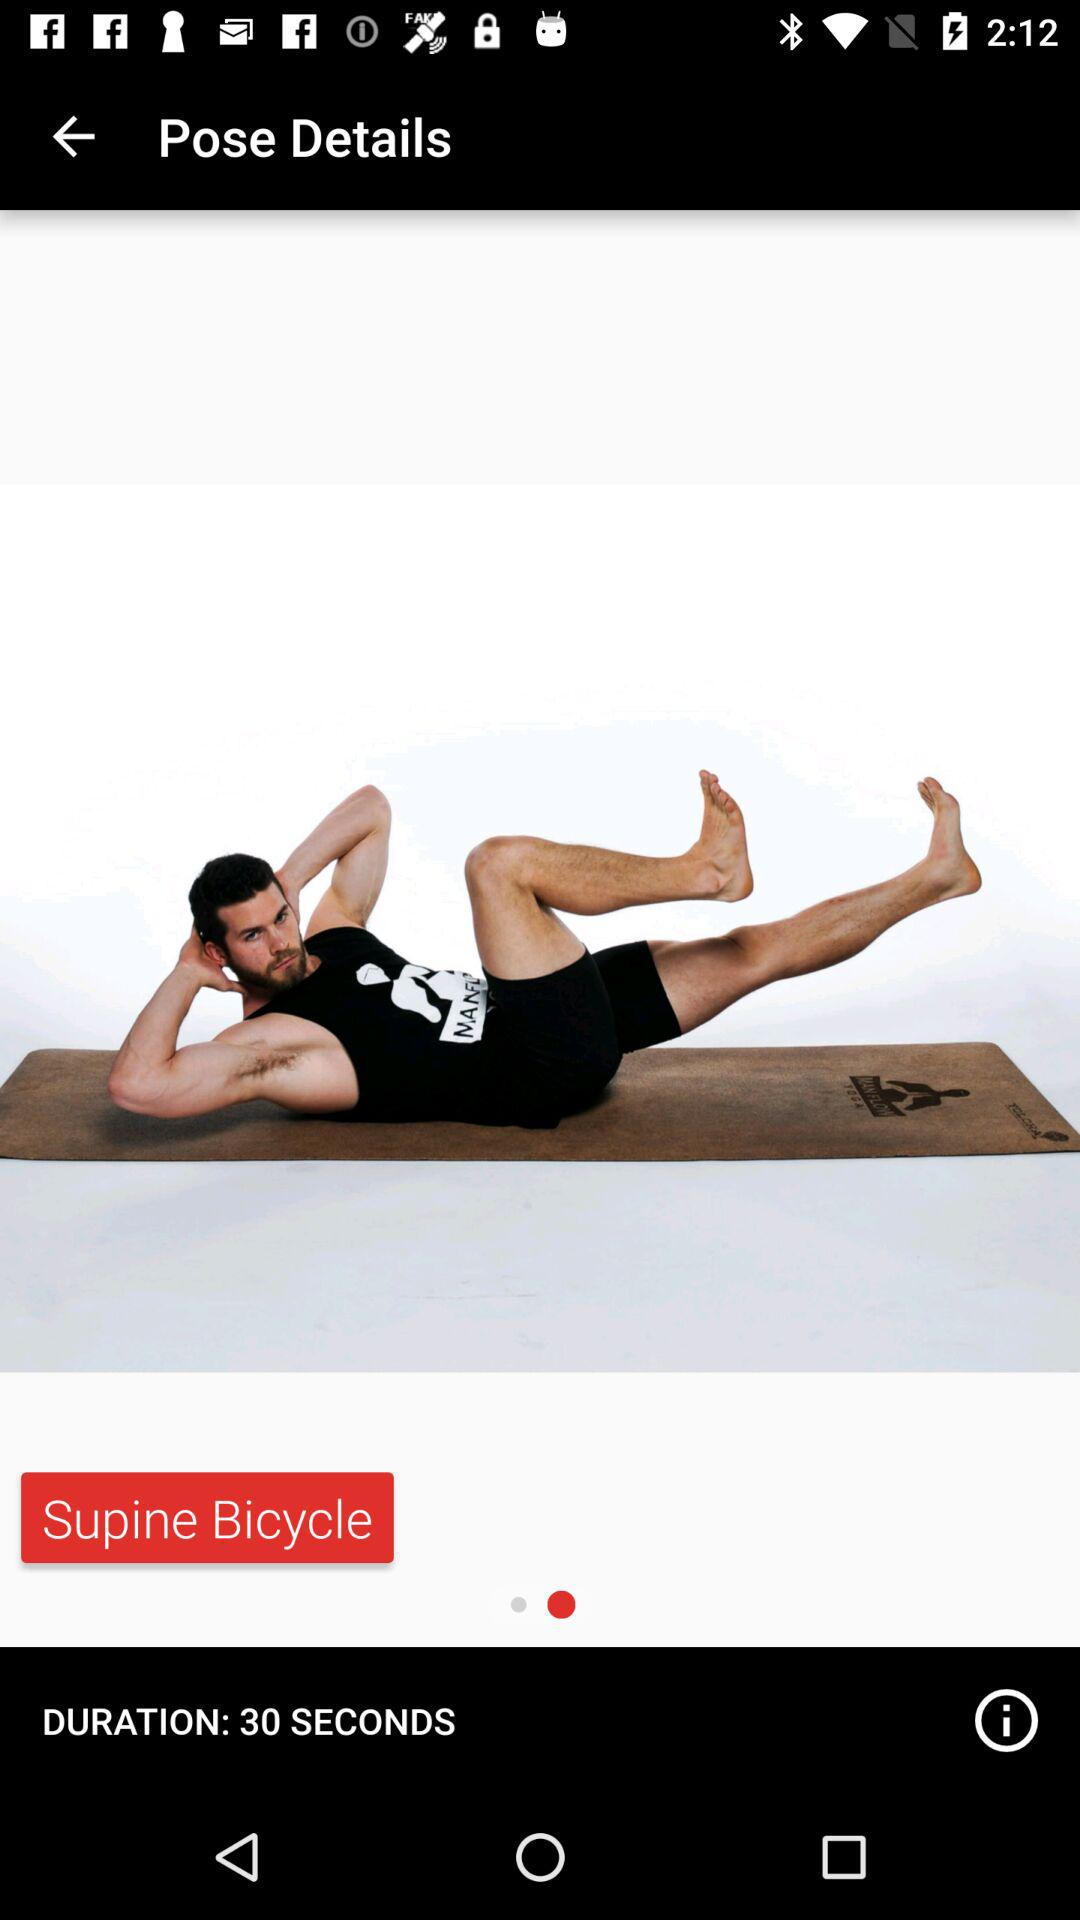What is the duration of the exercise? The duration of the exercise is 30 seconds. 